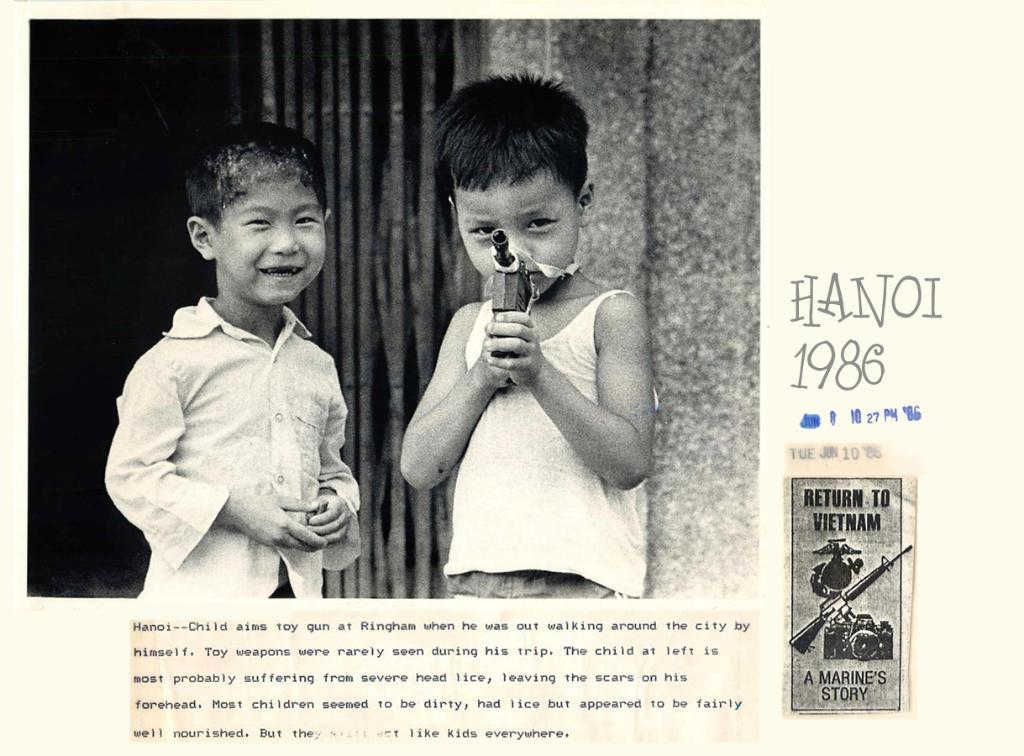In one or two sentences, can you explain what this image depicts? This picture is a black and white image. There are two boys standing and holding objects. There is one wall, one object looks like a gate, the background is dark on the left side of the image, some text on the bottom of the image, some text and numbers on the right side of the image. One sticker with text and images on the right side of the image. 